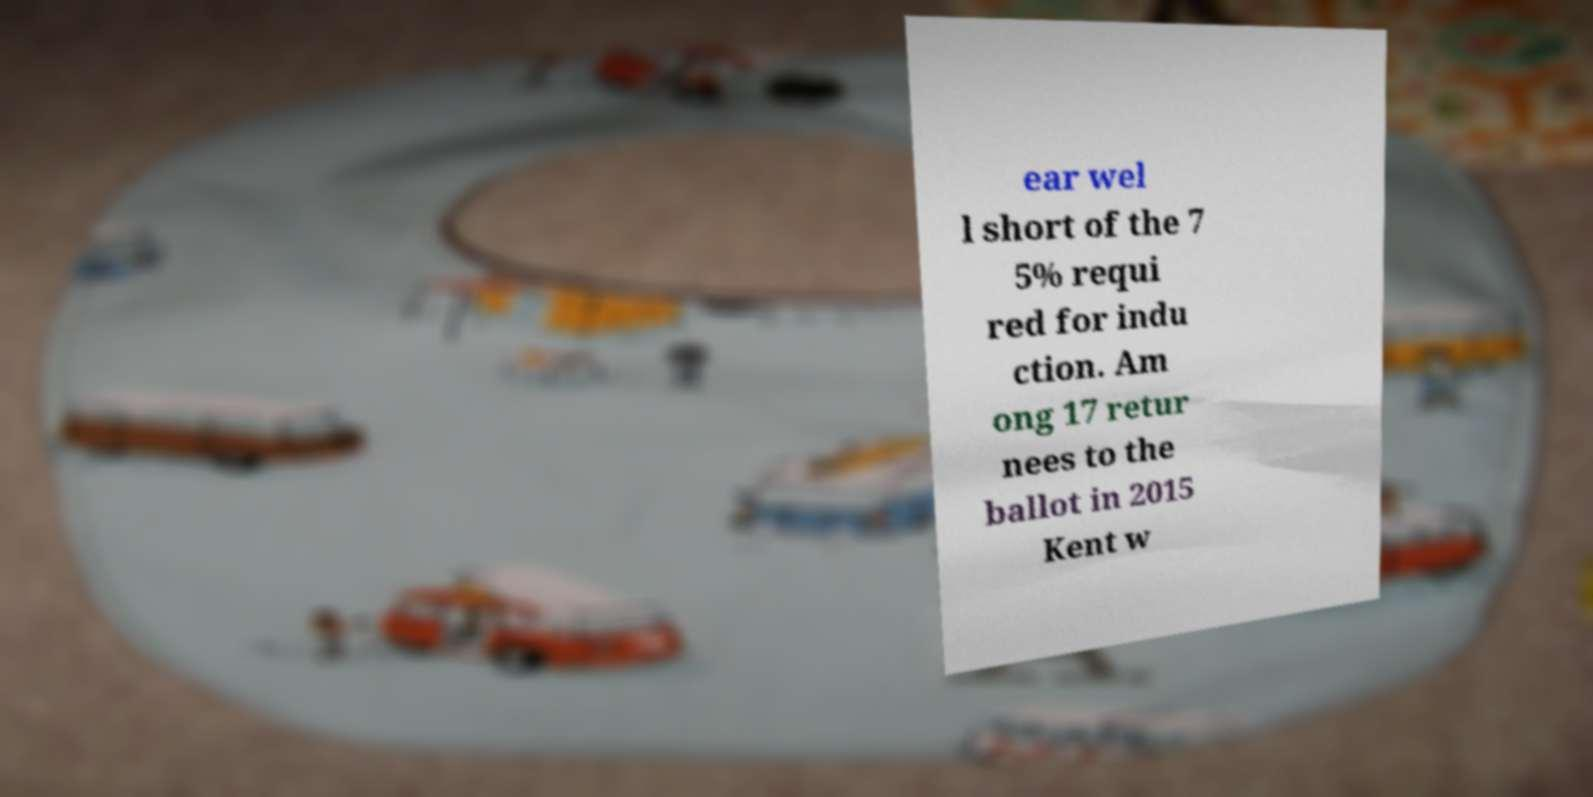There's text embedded in this image that I need extracted. Can you transcribe it verbatim? ear wel l short of the 7 5% requi red for indu ction. Am ong 17 retur nees to the ballot in 2015 Kent w 